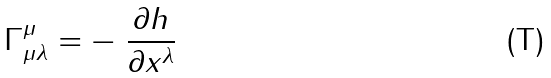<formula> <loc_0><loc_0><loc_500><loc_500>\Gamma _ { \mu \lambda } ^ { \mu } = - \ \frac { \partial h } { \partial x ^ { \lambda } }</formula> 